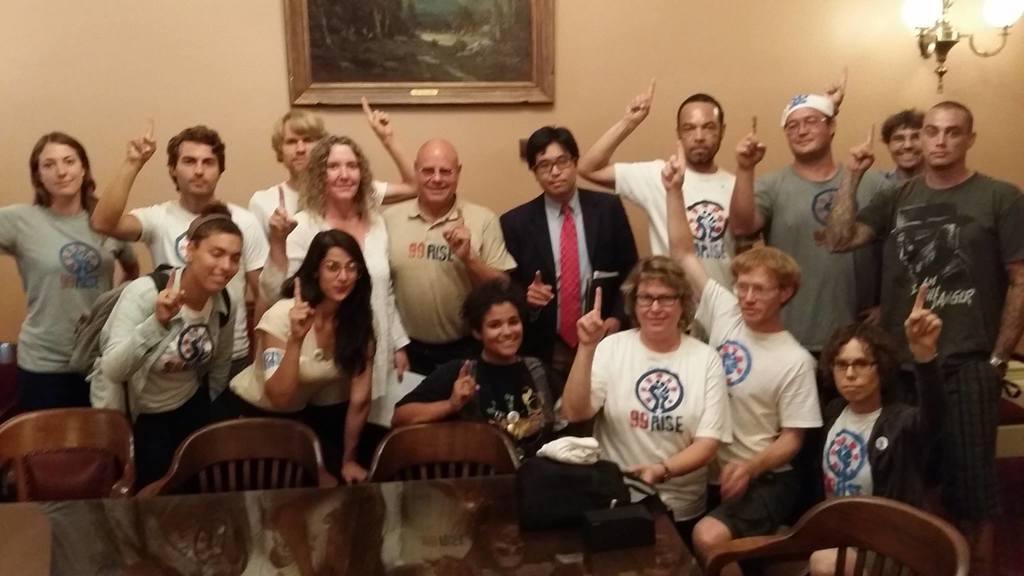Please provide a concise description of this image. There is a table and chairs at the bottom side of the image, there are people in the center. There is a frame and lamps at the top side. 